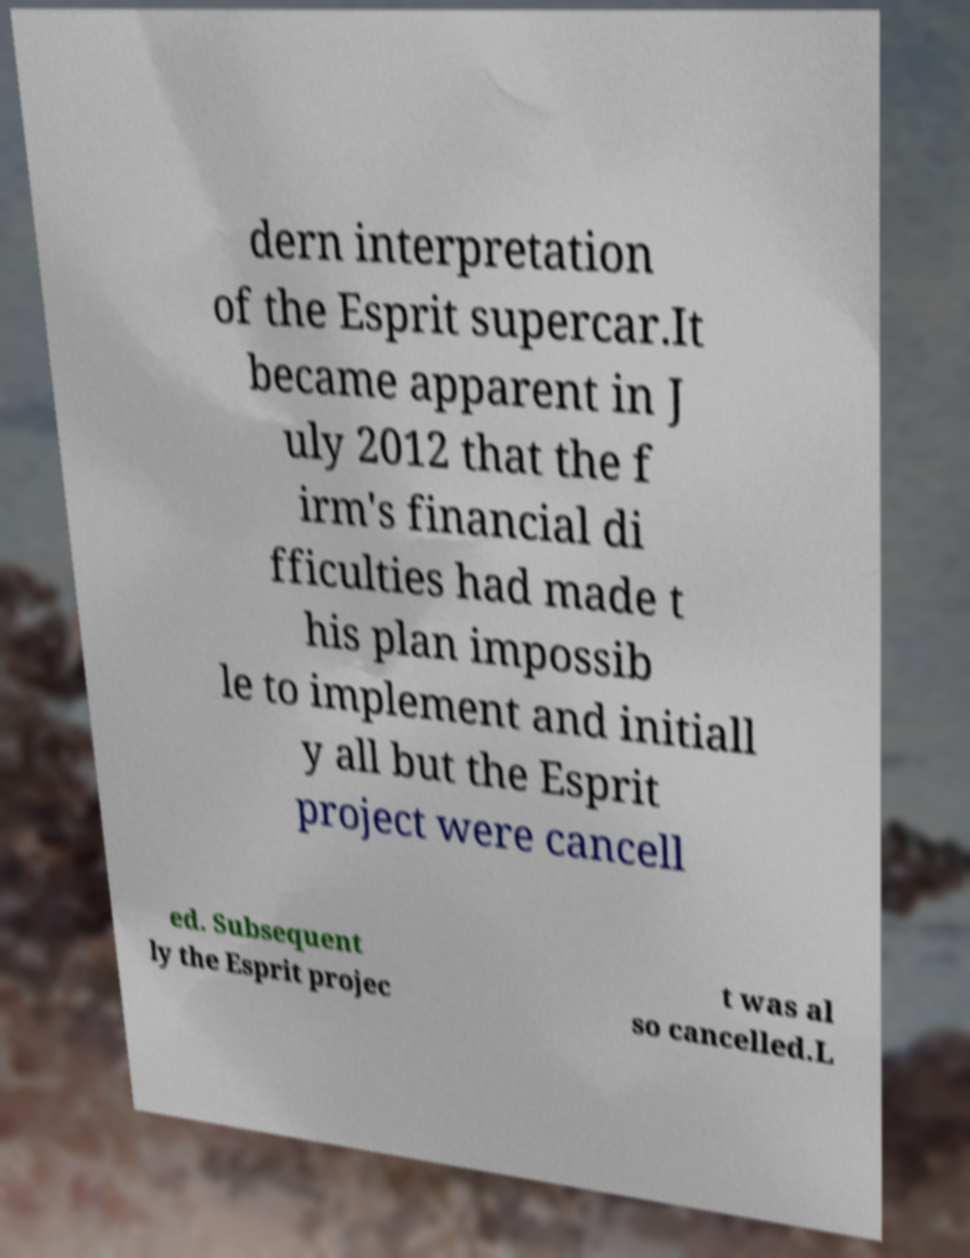For documentation purposes, I need the text within this image transcribed. Could you provide that? dern interpretation of the Esprit supercar.It became apparent in J uly 2012 that the f irm's financial di fficulties had made t his plan impossib le to implement and initiall y all but the Esprit project were cancell ed. Subsequent ly the Esprit projec t was al so cancelled.L 